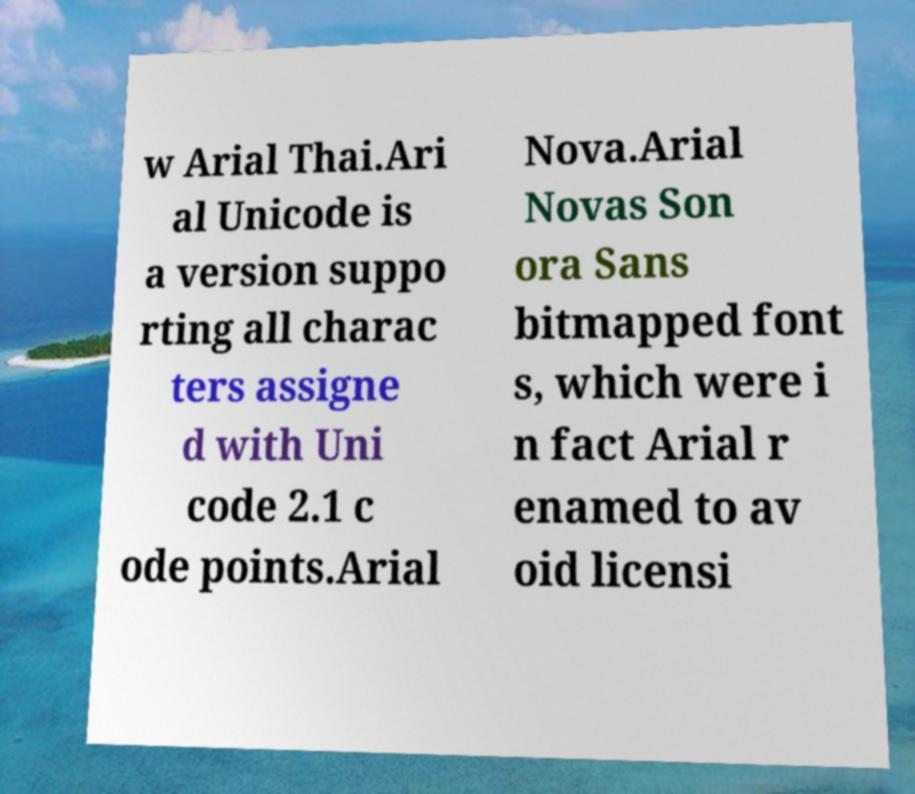Could you extract and type out the text from this image? w Arial Thai.Ari al Unicode is a version suppo rting all charac ters assigne d with Uni code 2.1 c ode points.Arial Nova.Arial Novas Son ora Sans bitmapped font s, which were i n fact Arial r enamed to av oid licensi 